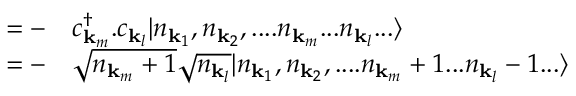Convert formula to latex. <formula><loc_0><loc_0><loc_500><loc_500>\begin{array} { r l } { - } & c _ { { k } _ { m } } ^ { \dagger } . c _ { { k } _ { l } } | n _ { { k } _ { 1 } } , n _ { { k } _ { 2 } } , \cdots n _ { { k } _ { m } } \dots n _ { { k } _ { l } } \dots \rangle } \\ { - } & { \sqrt { n _ { { k } _ { m } } + 1 } } { \sqrt { n _ { { k } _ { l } } } } | n _ { { k } _ { 1 } } , n _ { { k } _ { 2 } } , \cdots n _ { { k } _ { m } } + 1 \dots n _ { { k } _ { l } } - 1 \dots \rangle } \end{array}</formula> 